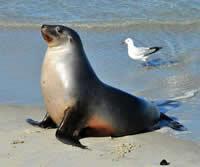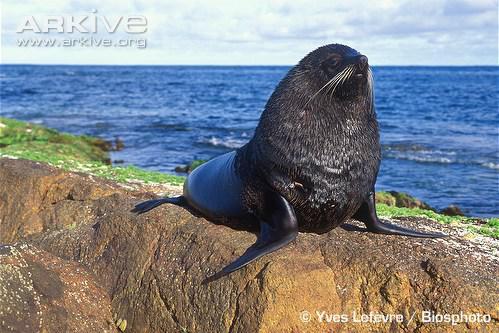The first image is the image on the left, the second image is the image on the right. Considering the images on both sides, is "Each image includes a seal with upright head and shoulders, and no seals are in the water." valid? Answer yes or no. Yes. The first image is the image on the left, the second image is the image on the right. Analyze the images presented: Is the assertion "None of the pictures have more than two seals in them." valid? Answer yes or no. Yes. 